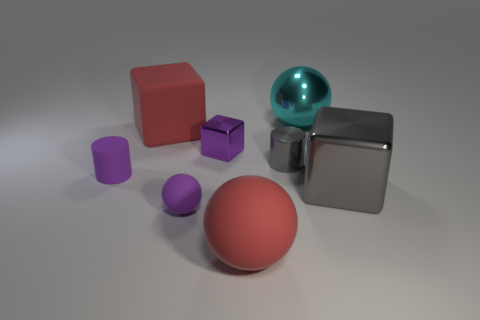Subtract 1 balls. How many balls are left? 2 Add 2 large cyan metal spheres. How many objects exist? 10 Subtract all cylinders. How many objects are left? 6 Subtract 0 blue cylinders. How many objects are left? 8 Subtract all big gray objects. Subtract all tiny metal cylinders. How many objects are left? 6 Add 8 matte blocks. How many matte blocks are left? 9 Add 6 small rubber spheres. How many small rubber spheres exist? 7 